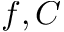Convert formula to latex. <formula><loc_0><loc_0><loc_500><loc_500>f , C</formula> 